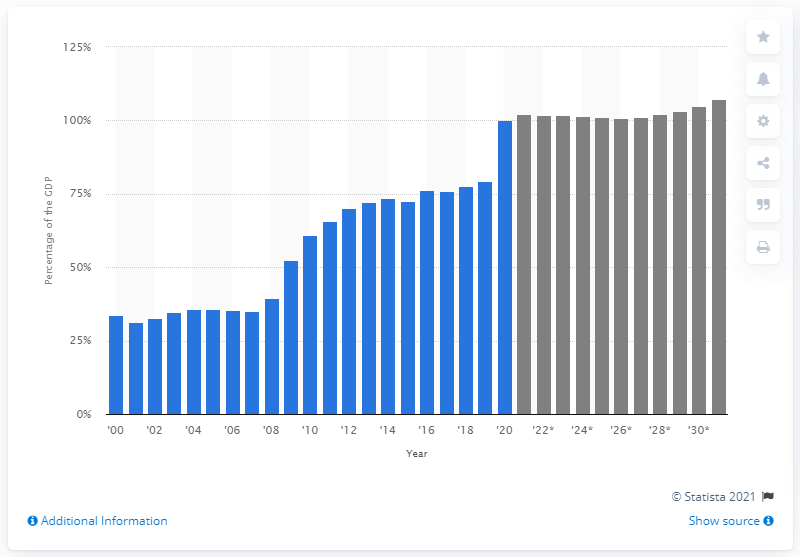List a handful of essential elements in this visual. The public debt is projected to increase by 107.2% of the GDP in 2031. In 2020, approximately 101% of the United States' Gross Domestic Product (GDP) was held by the public. 